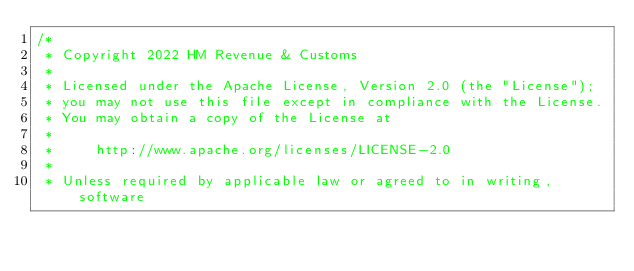<code> <loc_0><loc_0><loc_500><loc_500><_Scala_>/*
 * Copyright 2022 HM Revenue & Customs
 *
 * Licensed under the Apache License, Version 2.0 (the "License");
 * you may not use this file except in compliance with the License.
 * You may obtain a copy of the License at
 *
 *     http://www.apache.org/licenses/LICENSE-2.0
 *
 * Unless required by applicable law or agreed to in writing, software</code> 